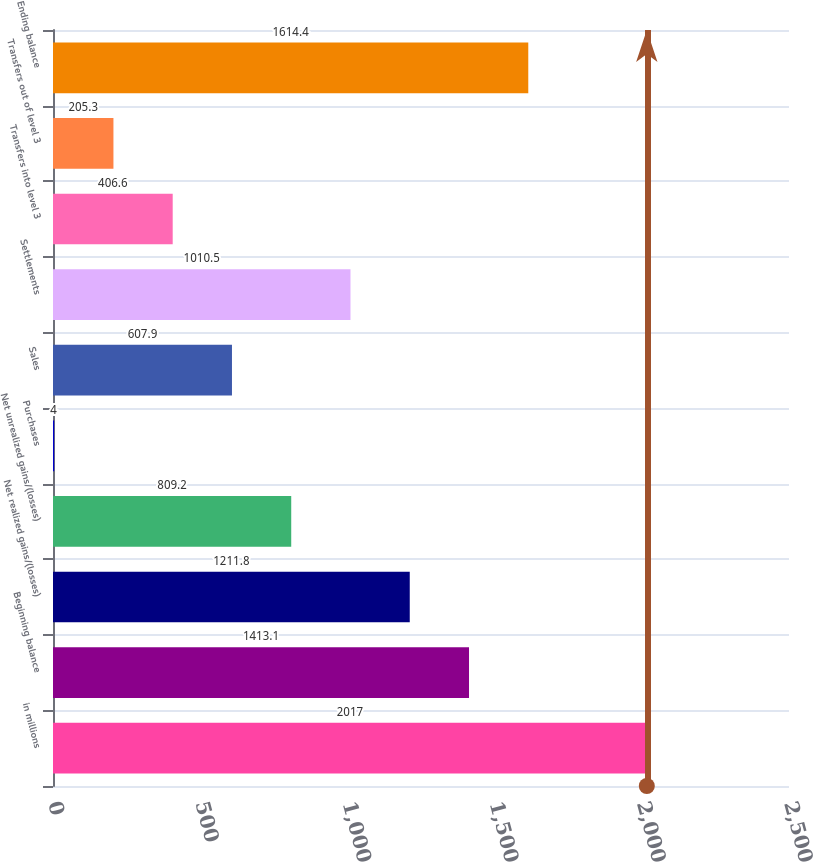Convert chart to OTSL. <chart><loc_0><loc_0><loc_500><loc_500><bar_chart><fcel>in millions<fcel>Beginning balance<fcel>Net realized gains/(losses)<fcel>Net unrealized gains/(losses)<fcel>Purchases<fcel>Sales<fcel>Settlements<fcel>Transfers into level 3<fcel>Transfers out of level 3<fcel>Ending balance<nl><fcel>2017<fcel>1413.1<fcel>1211.8<fcel>809.2<fcel>4<fcel>607.9<fcel>1010.5<fcel>406.6<fcel>205.3<fcel>1614.4<nl></chart> 